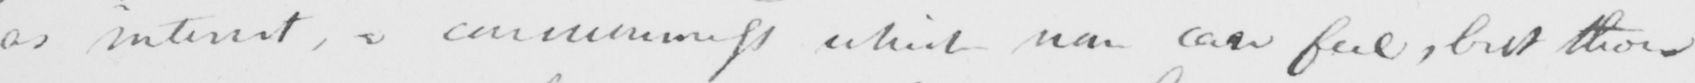Transcribe the text shown in this historical manuscript line. as well as interest , a consciousness which non can feel , but those 